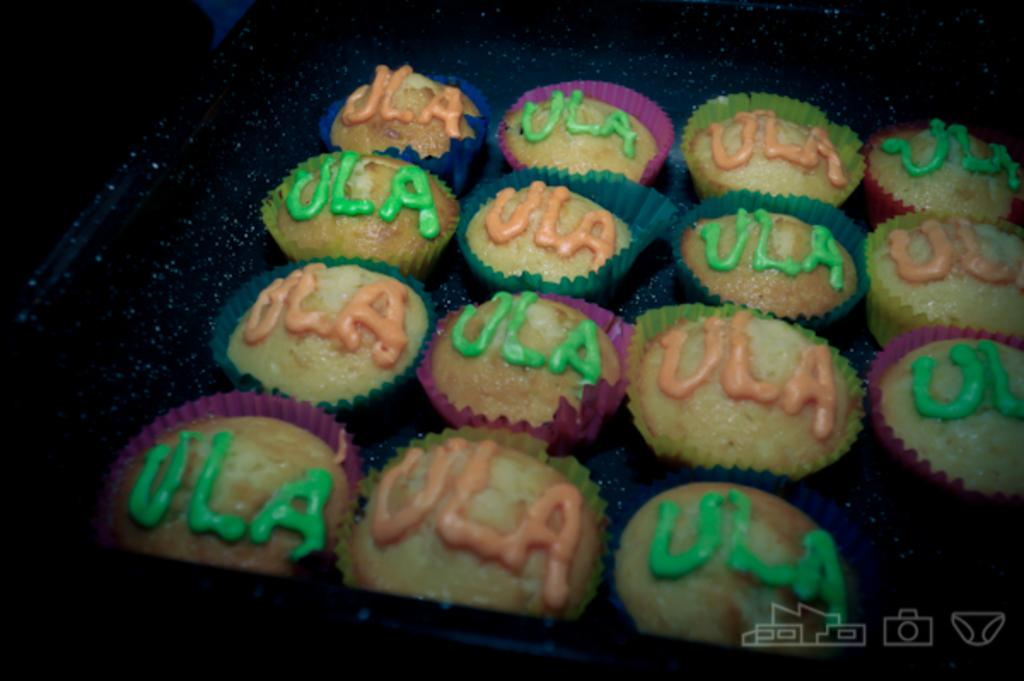What type of dessert is featured in the image? There are cupcakes in the image. What color is the background of the image? The background of the image is black. What type of cart is visible in the image? There is no cart present in the image. What material is the frame of the cupcakes made of? The image does not provide information about the material of the cupcakes' frame, as it only shows the cupcakes themselves. 